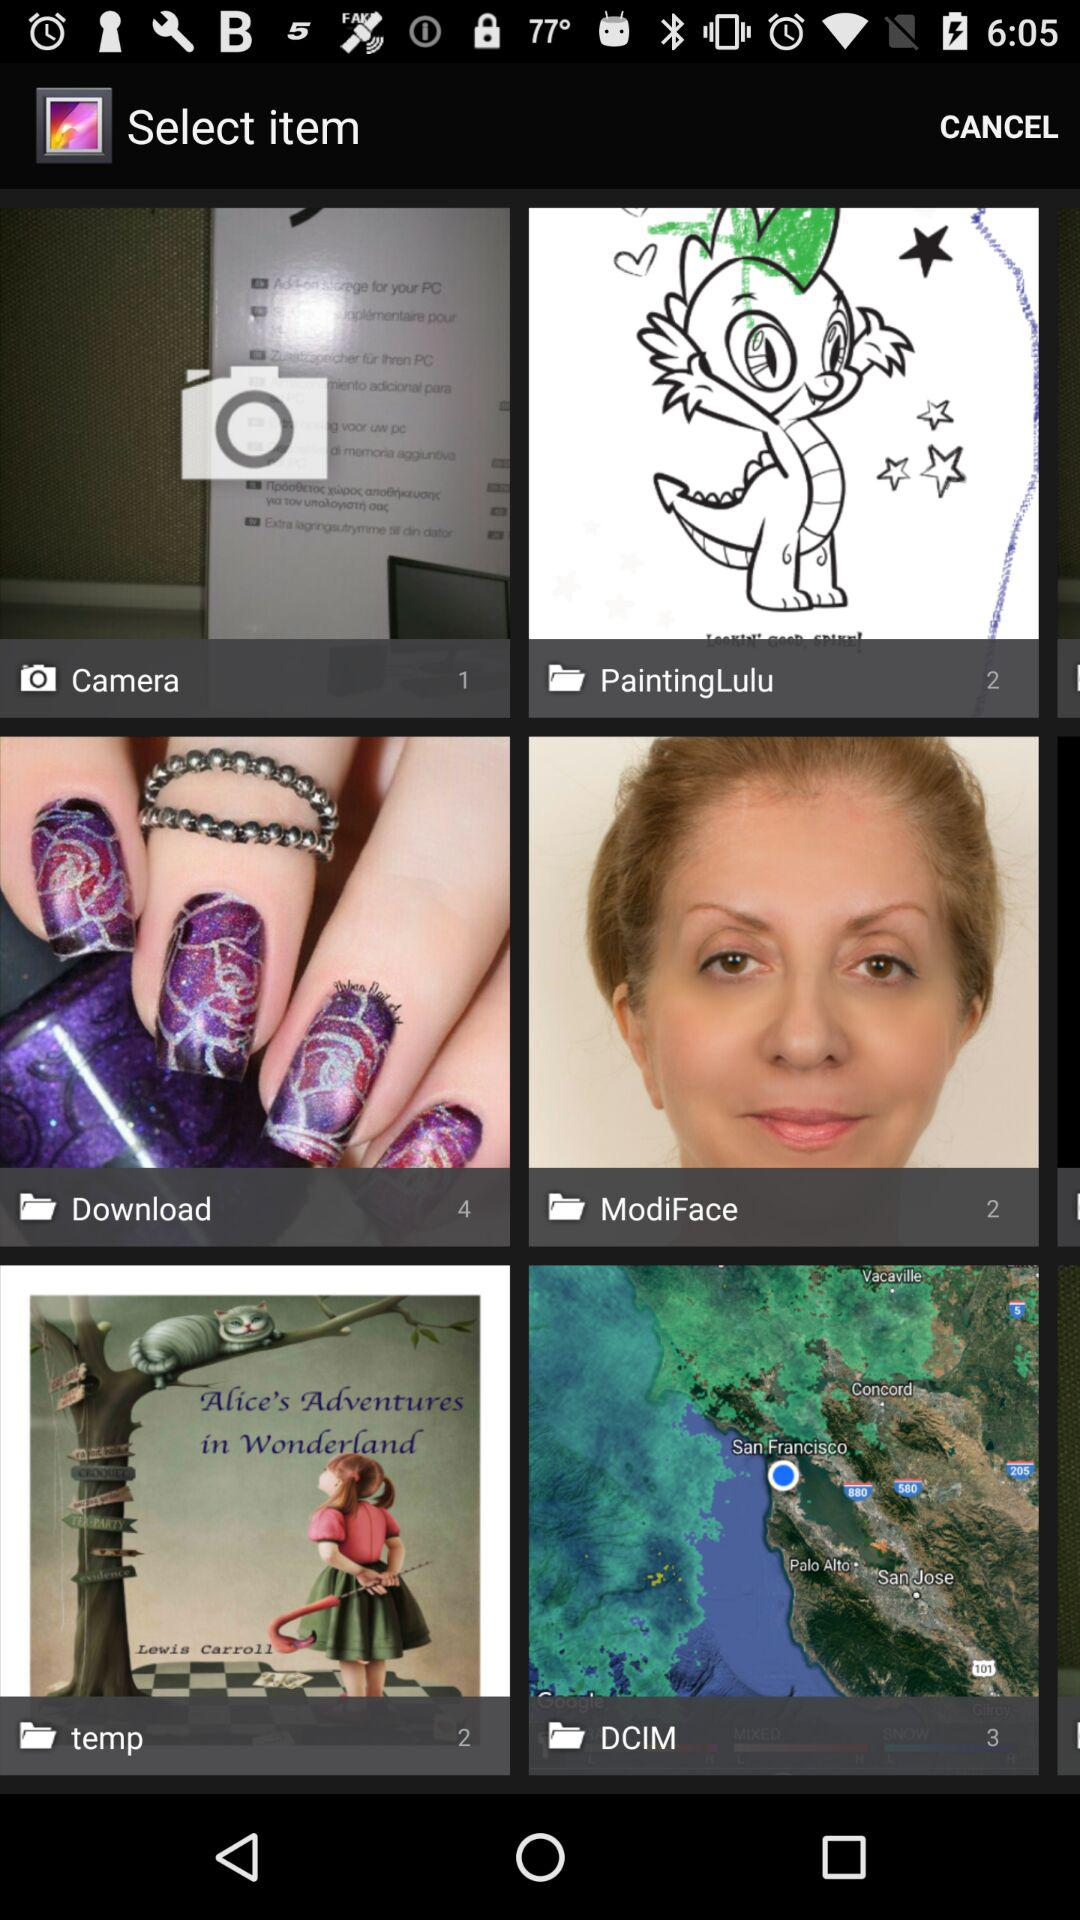What is the total number of images in the "Download" folder? The total number of images is 4. 